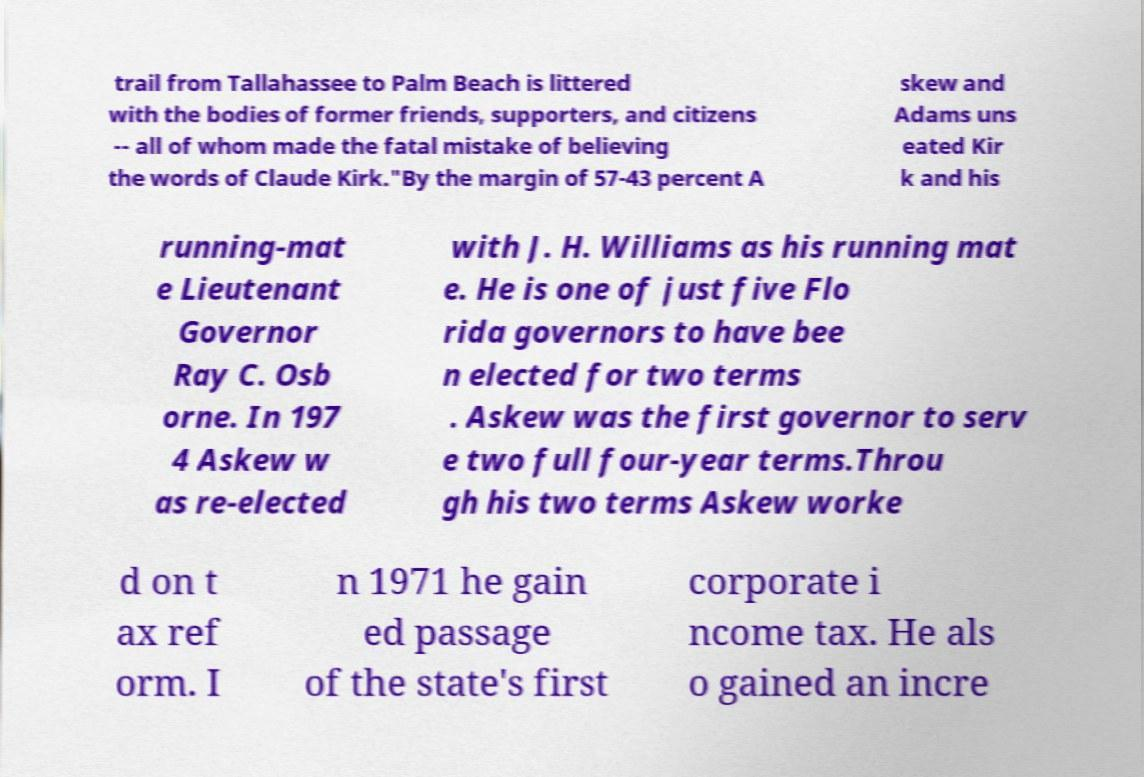Can you accurately transcribe the text from the provided image for me? trail from Tallahassee to Palm Beach is littered with the bodies of former friends, supporters, and citizens -- all of whom made the fatal mistake of believing the words of Claude Kirk."By the margin of 57-43 percent A skew and Adams uns eated Kir k and his running-mat e Lieutenant Governor Ray C. Osb orne. In 197 4 Askew w as re-elected with J. H. Williams as his running mat e. He is one of just five Flo rida governors to have bee n elected for two terms . Askew was the first governor to serv e two full four-year terms.Throu gh his two terms Askew worke d on t ax ref orm. I n 1971 he gain ed passage of the state's first corporate i ncome tax. He als o gained an incre 